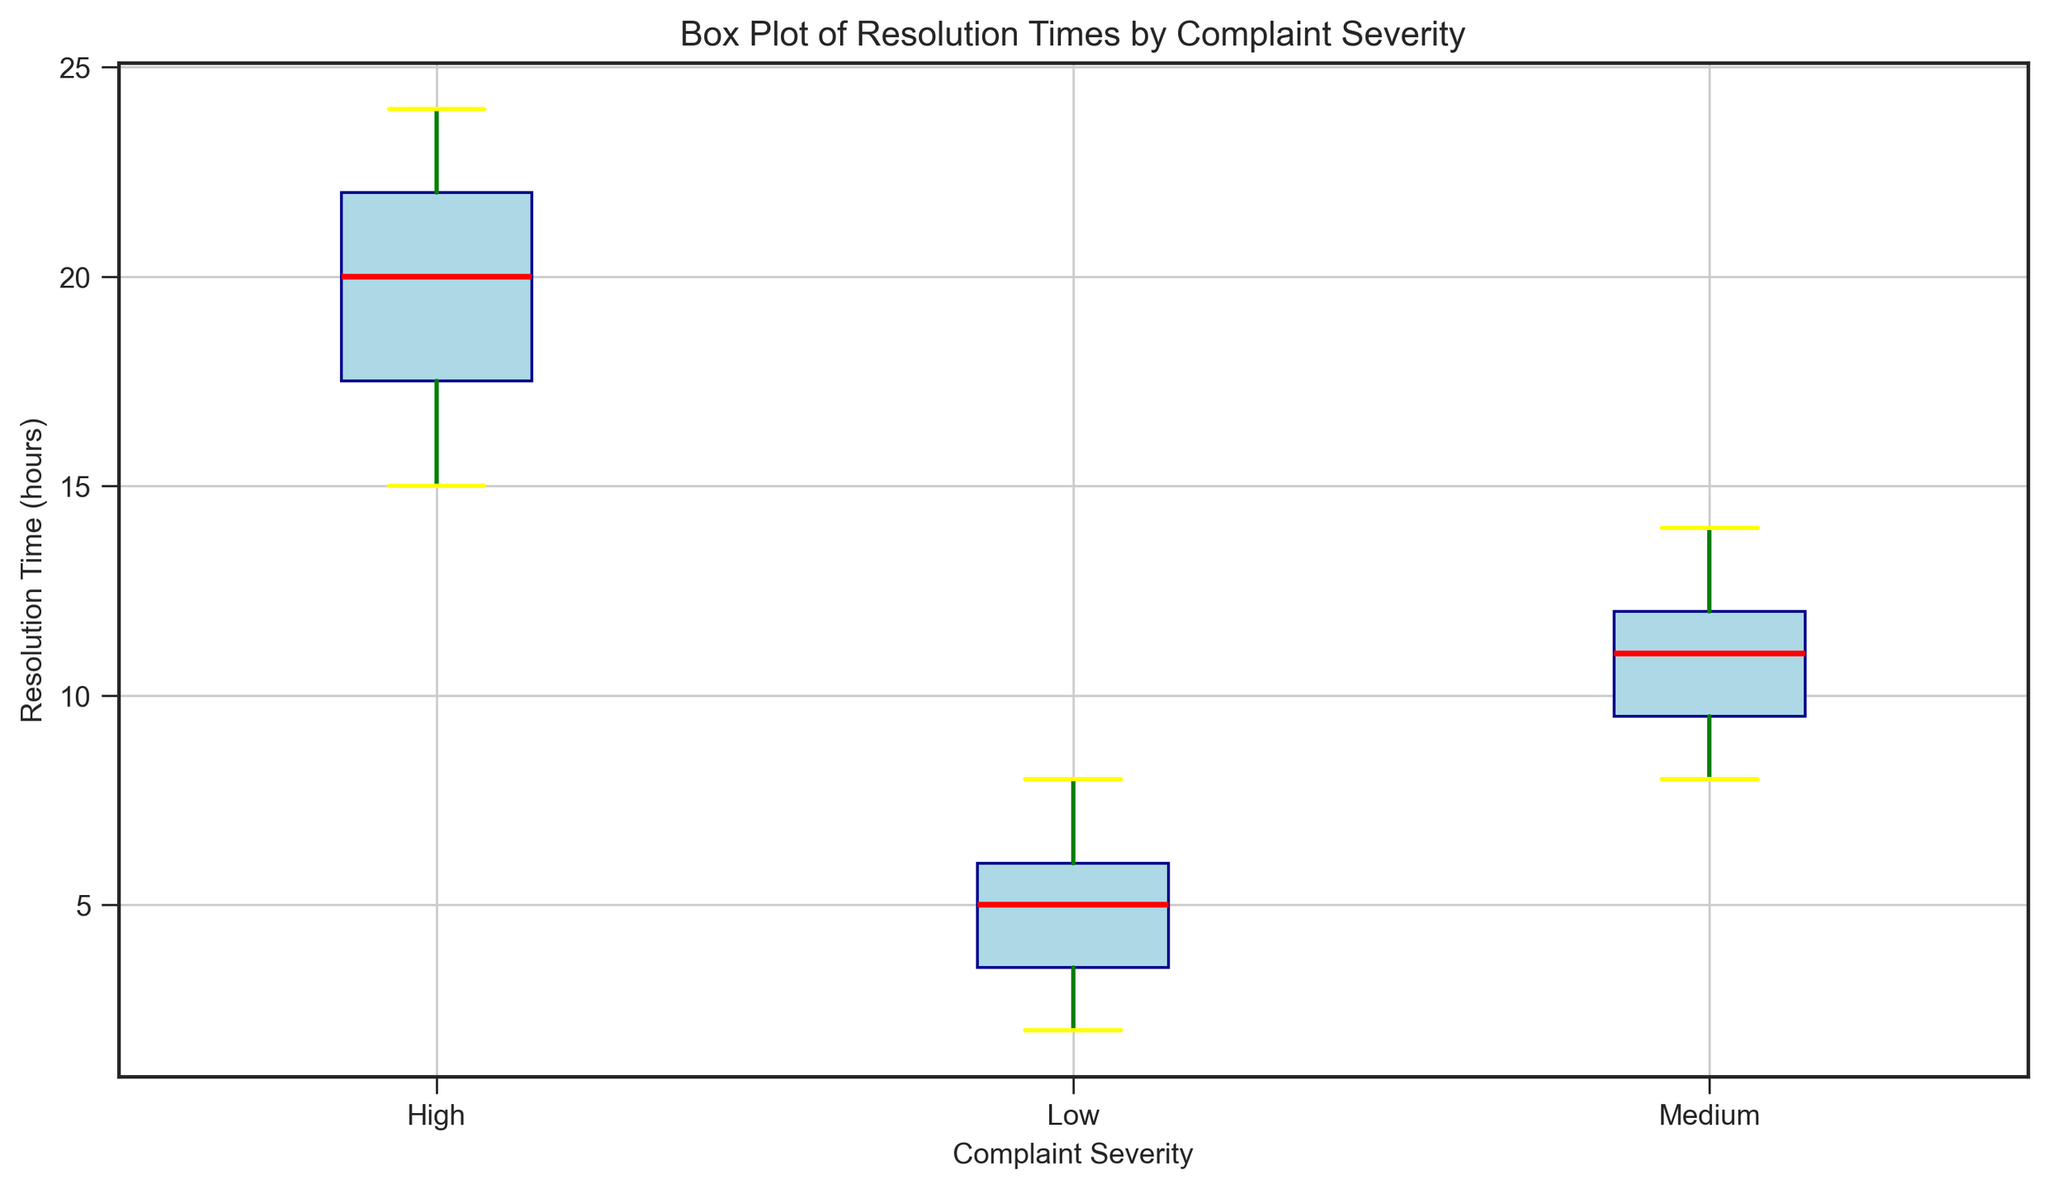What is the median Resolution Time for Medium severity complaints? The median is the middle value in a sorted list of numbers. By looking at the box plot, the red line inside the box for Medium severity indicates the median Resolution Time. The red line is positioned at 11.
Answer: 11 Which Complaint Severity level has the highest median Resolution Time? To compare the median values, look at the red lines within each of the boxes for all severity levels. The box for High severity has the highest median Resolution Time.
Answer: High What is the interquartile range (IQR) for Low severity complaints? IQR is calculated as the difference between the upper quartile (Q3) and the lower quartile (Q1). The top and bottom edges of the box plot represent Q3 and Q1 respectively. For Low severity complaints, the box extends from roughly 4 to 6, so the IQR is 6 - 4 = 2.
Answer: 2 Which Complaint Severity level has the widest range in Resolution Times, and what is that range? The range is calculated as the difference between the maximum and minimum values shown by the whiskers. For Low, it ranges from about 2 to 8 (8−2=6). For Medium, it ranges from about 8 to 14 (14−8=6). For High, it ranges from about 15 to 24 (24−15=9). Therefore, High severity has the widest range.
Answer: High, 9 How do the median Resolution Times for Low and High severity complaints compare? Compare the red median lines within the respective boxes. The median for Low severity is around 5, whereas for High severity, it is significantly higher, around 20. Thus, the median for High is much greater.
Answer: The median for High is much greater Are there any outliers in the Resolution Times for Medium severity complaints? Outliers are indicated by points outside the whiskers in a box plot. For Medium severity, there are no outliers shown, as all points fall within the whiskers.
Answer: No Which Complaint Severity has the smallest spread (variance) in Resolution Times? The spread or variance can be visually assessed by the size of the box and the total length of the whiskers. Low severity has the smallest spread since its box and whiskers are compressed compared to Medium and High.
Answer: Low Compare the upper quartile (Q3) values for Medium and High severity complaints. Q3 is represented by the top edge of the box. For Medium severity, Q3 is around 12, while for High severity, it is around 22.
Answer: High severity's Q3 is much higher What is the maximum Resolution Time for Low and Medium severity complaints? The maximum is indicated by the top end of the whiskers. For Low severity, it is about 8. For Medium severity, it is about 14.
Answer: Low: 8, Medium: 14 Is the distribution of Resolution Times more symmetric for Low or Medium severity complaints? Symmetry in a box plot is indicated by the median line being centrally located within the box and equidistant whiskers. Low severity appears more symmetric with a more centered median and nearly equal whiskers.
Answer: Low 